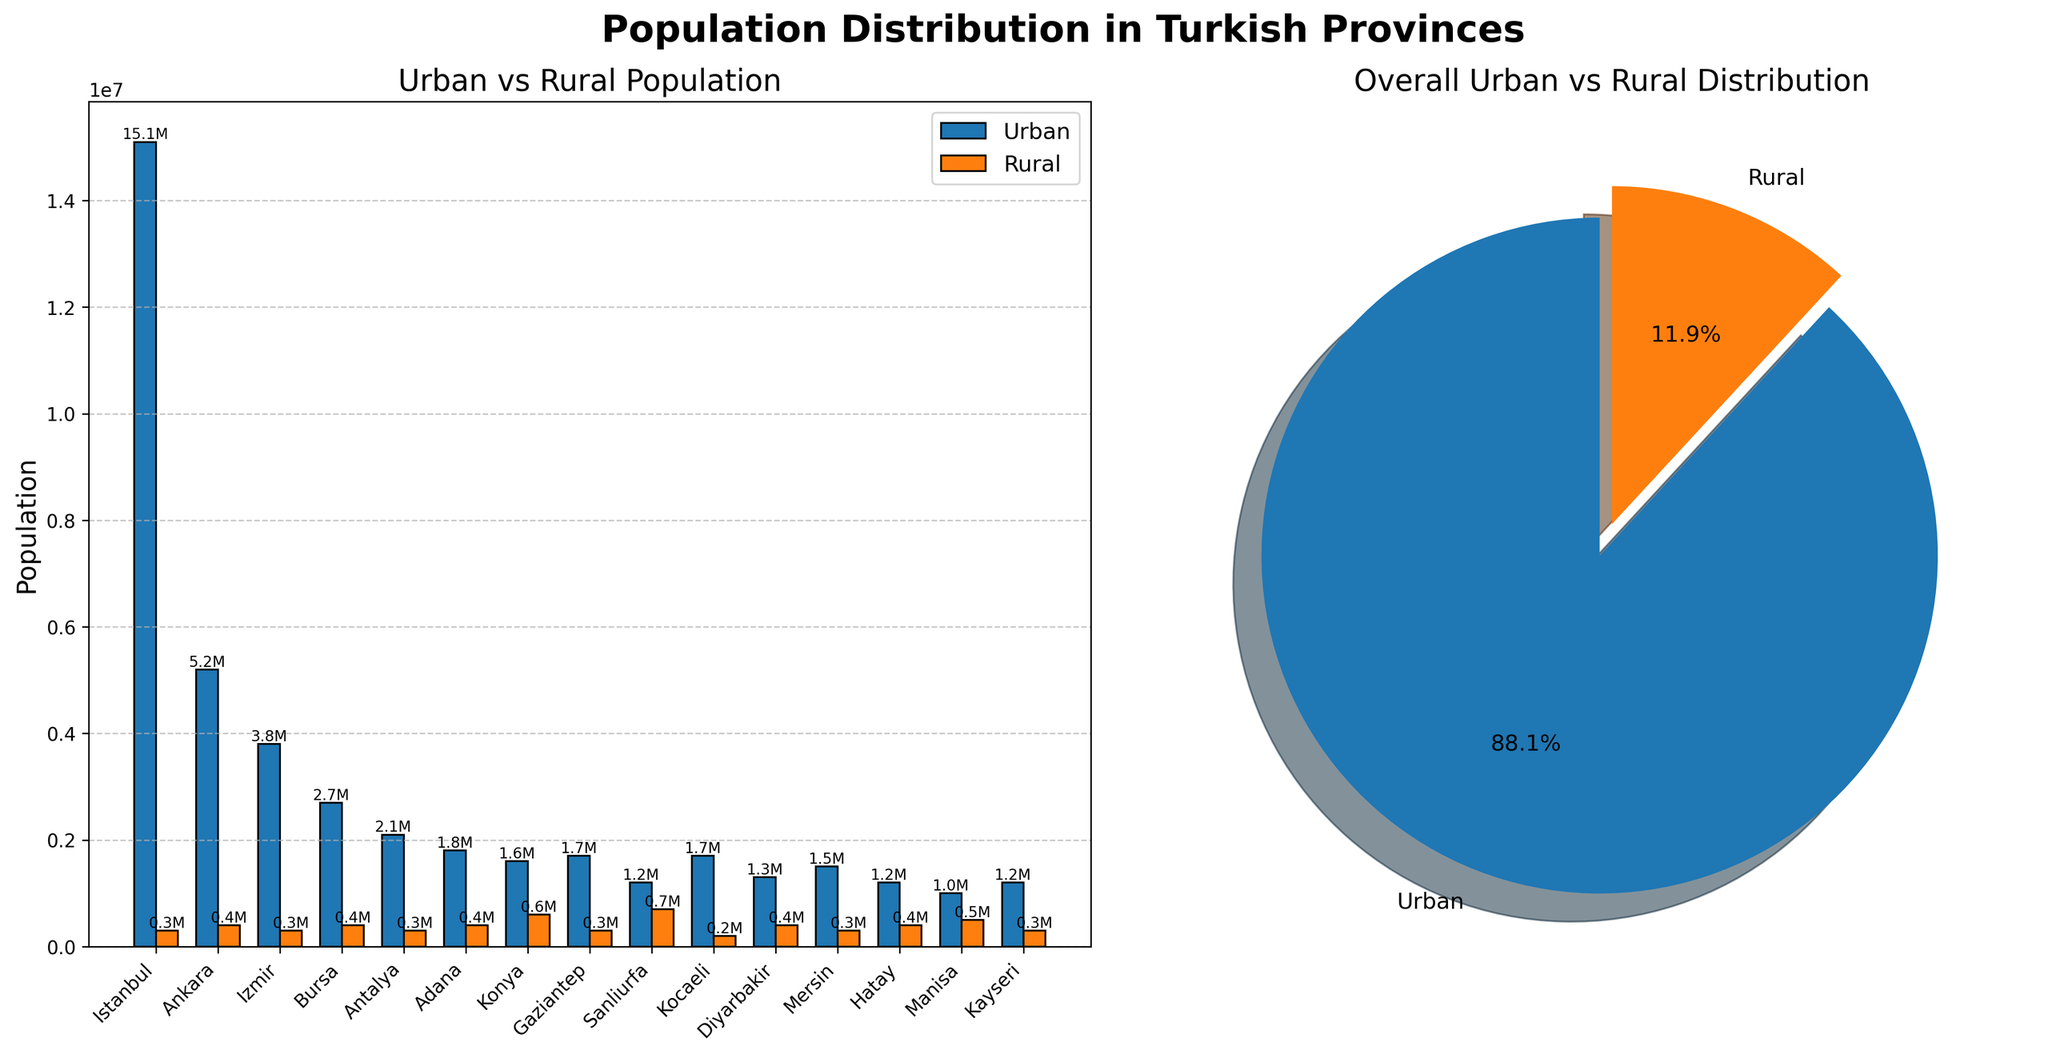What is the total population for Istanbul? To find the total population for Istanbul, sum the urban and rural populations. The urban population is 15,100,000 and the rural population is 300,000. Therefore, 15,100,000 + 300,000 = 15,400,000.
Answer: 15,400,000 What is the title of the pie chart? The title of the pie chart appears on top of the pie chart subplot. It reads "Overall Urban vs Rural Distribution".
Answer: Overall Urban vs Rural Distribution Which province has the highest rural population? By comparing the rural population of each province, Sanliurfa has the highest rural population with 700,000.
Answer: Sanliurfa What percentage of the total population is urban? From the pie chart, the urban population percentage is given. The percentage is 85.5%.
Answer: 85.5% Which provinces have a higher urban population than rural population? Compare the urban and rural population bars for each province. Provinces with a higher urban population than rural include Istanbul, Ankara, Izmir, Bursa, Antalya, Adana, Gaziantep, Kocaeli, Diyarbakir, Mersin, Hatay, and Kayseri.
Answer: Istanbul, Ankara, Izmir, Bursa, Antalya, Adana, Gaziantep, Kocaeli, Diyarbakir, Mersin, Hatay, Kayseri In terms of urban population, which provinces are in the top three? To determine the provinces with the highest urban population, compare the heights of the urban population bars. The top three provinces by urban population are Istanbul, Ankara, and Izmir.
Answer: Istanbul, Ankara, Izmir Between Konya and Gaziantep, which has a larger rural population? Compare the rural population bars for Konya and Gaziantep. Konya has a rural population of 600,000, while Gaziantep has 300,000. Therefore, Konya has a larger rural population.
Answer: Konya What is the combined population of the three least populated provinces? Identify the three provinces with the lowest combined urban and rural population by examining the bars. They are Manisa, Kayseri, and Hatay. Add their populations: Manisa (1,000,000 + 500,000), Kayseri (1,200,000 + 300,000), Hatay (1,200,000 + 400,000). Therefore, (1,500,000) + (1,500,000) + (1,600,000) = 4,600,000.
Answer: 4,600,000 